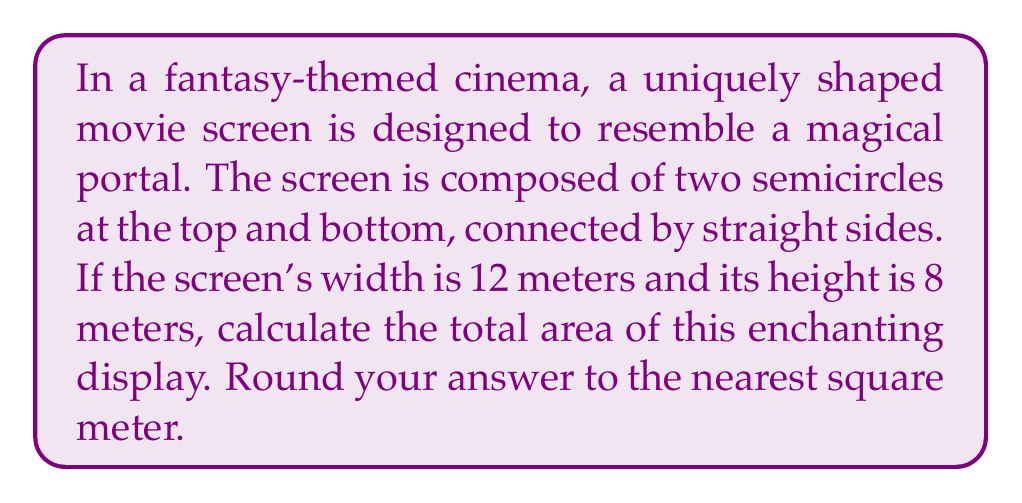Provide a solution to this math problem. Let's approach this step-by-step:

1) The screen can be divided into three parts: a rectangle in the middle and two semicircles at the top and bottom.

2) Let's calculate the area of the rectangle first:
   Width = 12 m
   Height of rectangle = Total height - Diameter of semicircle = 8 - 12 = -4 m
   
   Since the height is negative, it means the semicircles overlap. The rectangle doesn't exist in this case.

3) Now, let's calculate the area of a full circle with diameter 12 m:
   Radius = 12/2 = 6 m
   Area of full circle = $\pi r^2 = \pi (6)^2 = 36\pi$ m²

4) The screen consists of two semicircles, which is equivalent to one full circle:
   Area of screen = $36\pi$ m²

5) Converting to square meters and rounding to the nearest integer:
   $36\pi \approx 113.097$ m²
   Rounded to the nearest square meter: 113 m²

[asy]
import geometry;

size(200);

path c1 = Circle((0,4), 6);
path c2 = Circle((0,-4), 6);

draw(c1);
draw(c2);

draw((-6,-8)--(6,-8));
draw((-6,8)--(6,8));

label("12 m", (0,-8), S);
label("8 m", (6,0), E);
[/asy]
Answer: 113 m² 